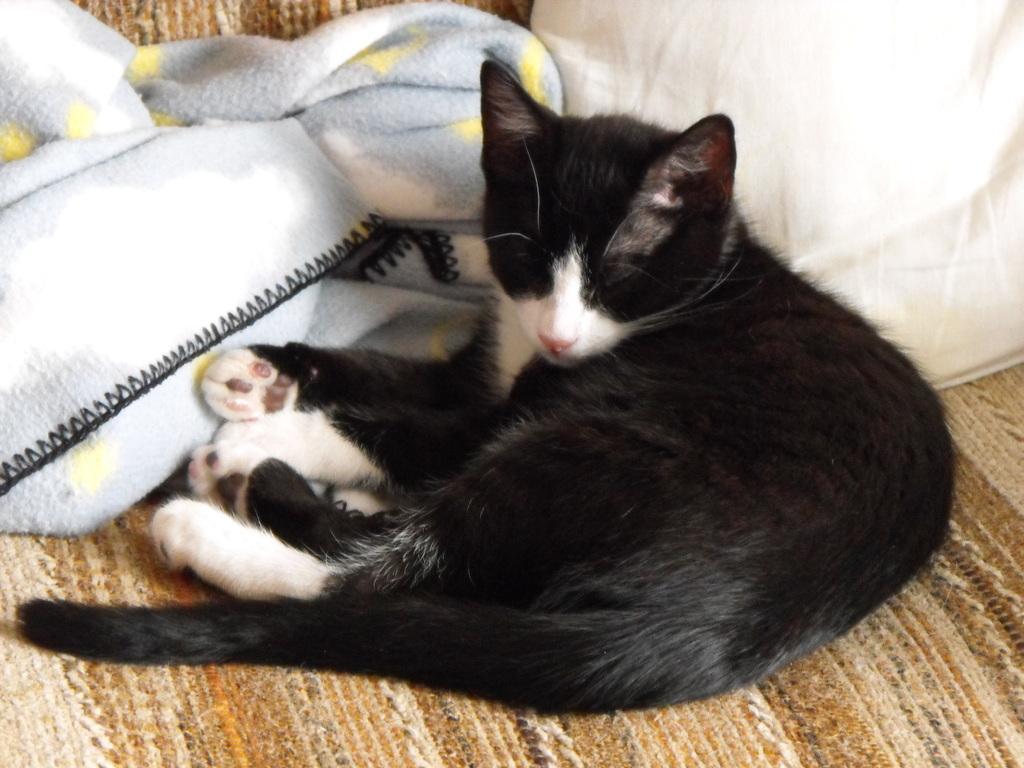Could you give a brief overview of what you see in this image? In this image, we can see a cat on the mat. There are clothes in the middle of the image. 